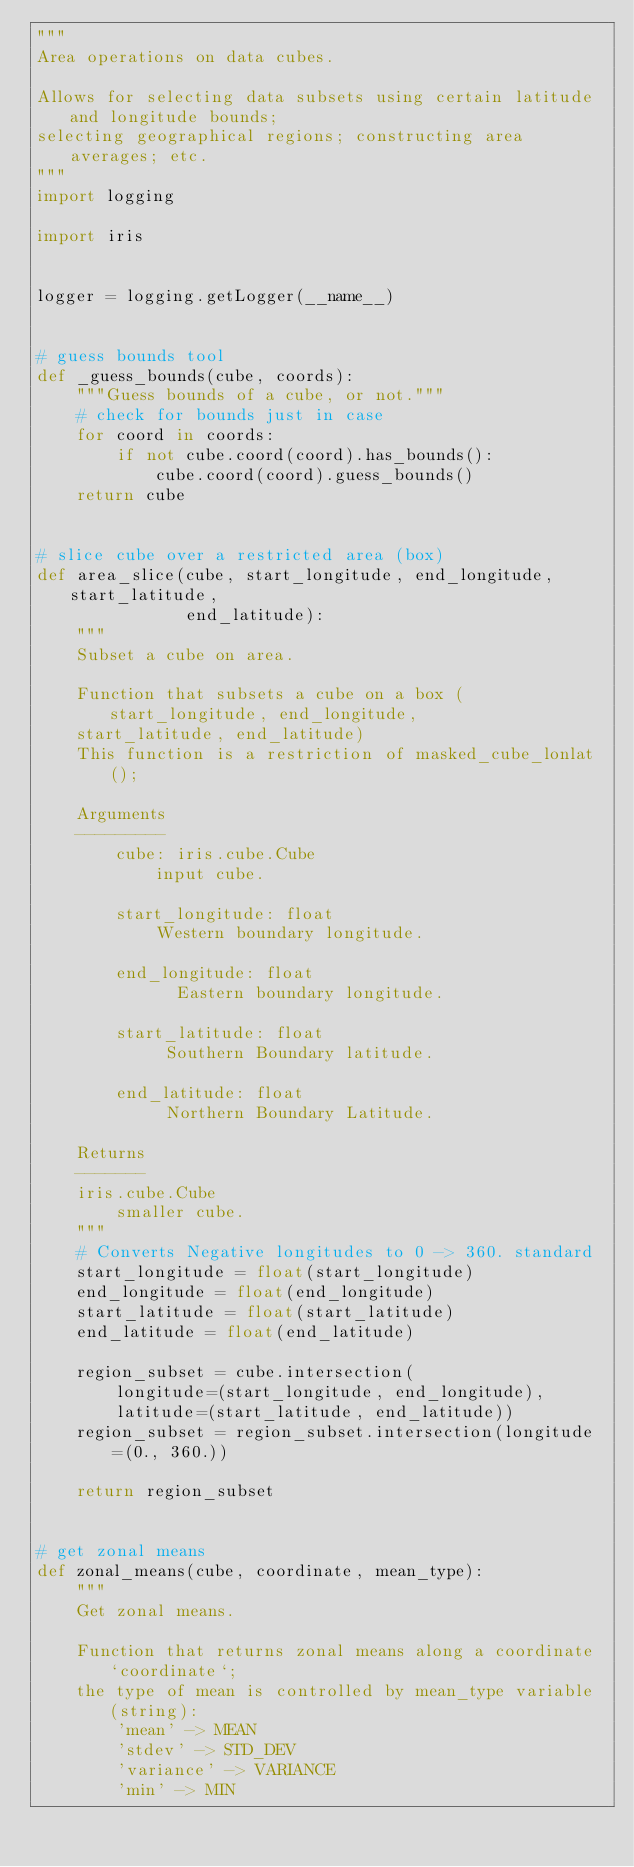<code> <loc_0><loc_0><loc_500><loc_500><_Python_>"""
Area operations on data cubes.

Allows for selecting data subsets using certain latitude and longitude bounds;
selecting geographical regions; constructing area averages; etc.
"""
import logging

import iris


logger = logging.getLogger(__name__)


# guess bounds tool
def _guess_bounds(cube, coords):
    """Guess bounds of a cube, or not."""
    # check for bounds just in case
    for coord in coords:
        if not cube.coord(coord).has_bounds():
            cube.coord(coord).guess_bounds()
    return cube


# slice cube over a restricted area (box)
def area_slice(cube, start_longitude, end_longitude, start_latitude,
               end_latitude):
    """
    Subset a cube on area.

    Function that subsets a cube on a box (start_longitude, end_longitude,
    start_latitude, end_latitude)
    This function is a restriction of masked_cube_lonlat();

    Arguments
    ---------
        cube: iris.cube.Cube
            input cube.

        start_longitude: float
            Western boundary longitude.

        end_longitude: float
              Eastern boundary longitude.

        start_latitude: float
             Southern Boundary latitude.

        end_latitude: float
             Northern Boundary Latitude.

    Returns
    -------
    iris.cube.Cube
        smaller cube.
    """
    # Converts Negative longitudes to 0 -> 360. standard
    start_longitude = float(start_longitude)
    end_longitude = float(end_longitude)
    start_latitude = float(start_latitude)
    end_latitude = float(end_latitude)

    region_subset = cube.intersection(
        longitude=(start_longitude, end_longitude),
        latitude=(start_latitude, end_latitude))
    region_subset = region_subset.intersection(longitude=(0., 360.))

    return region_subset


# get zonal means
def zonal_means(cube, coordinate, mean_type):
    """
    Get zonal means.

    Function that returns zonal means along a coordinate `coordinate`;
    the type of mean is controlled by mean_type variable (string):
        'mean' -> MEAN
        'stdev' -> STD_DEV
        'variance' -> VARIANCE
        'min' -> MIN</code> 